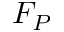<formula> <loc_0><loc_0><loc_500><loc_500>F _ { P }</formula> 